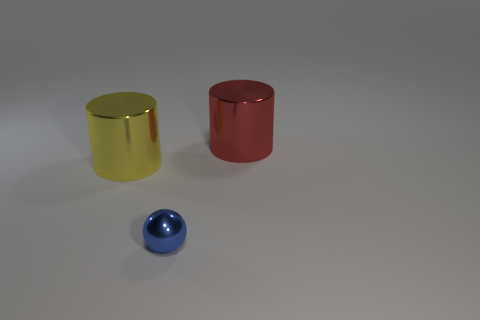Are these objects showing any shadows? Yes, each object casts a distinct shadow to its side, indicating a light source coming from the opposite direction, and the shadows help to emphasize the three-dimensionality of the objects. 